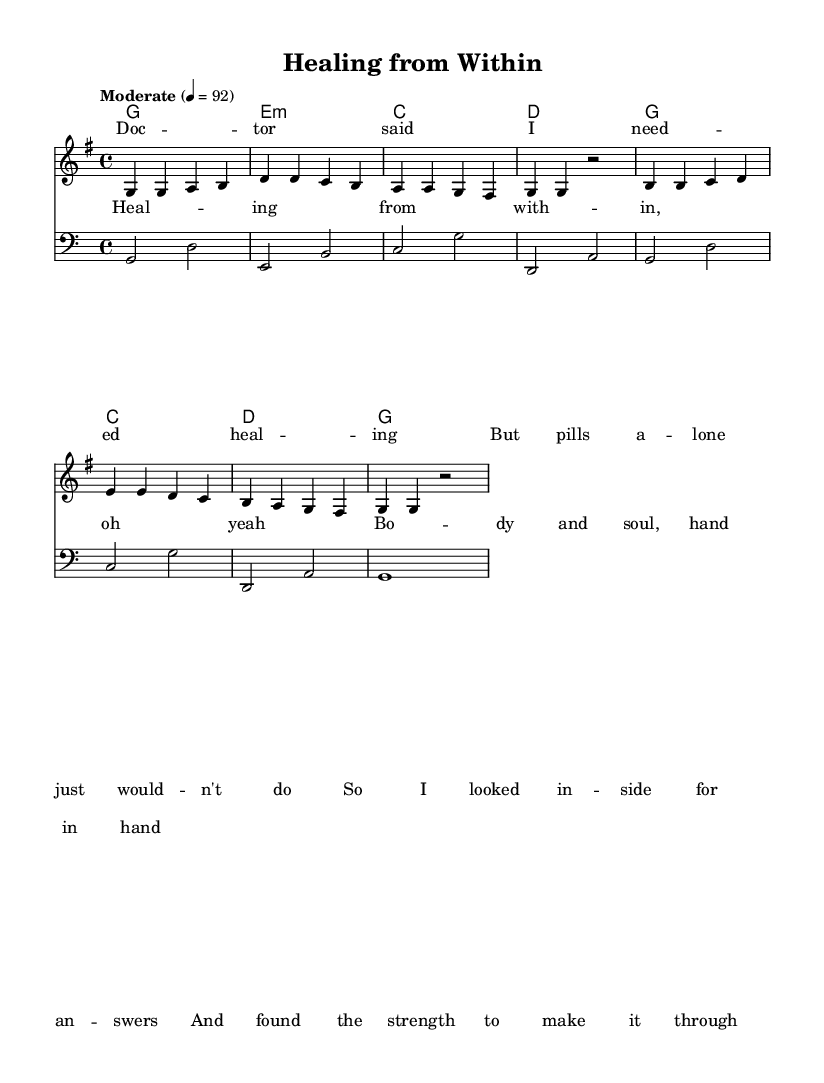What is the key signature of this music? The key signature is G major, which contains one sharp (F#). This can be identified at the beginning of the staff where the sharp symbol is placed.
Answer: G major What is the time signature of this music? The time signature displayed at the beginning is 4/4, indicating four beats per measure, with a quarter note receiving one beat. This is noted directly following the key signature.
Answer: 4/4 What is the tempo marking for this piece? The tempo marking is "Moderate," set at a quarter note = 92 beats per minute. This is commonly found near the title of the score, informing musicians about the expected speed of the piece.
Answer: Moderate, 92 How many measures are in the melody section provided? The melody section shows four measures in the first line and four in the second line, totaling eight measures. By counting the vertical lines separating each measure, we can determine the total.
Answer: 8 What is the main theme of the lyrics in this song? The lyrics focus on the theme of healing from within, as described in the verses and chorus. Interpreting the words from the lyric sections reveals an emphasis on self-discovery and resilience.
Answer: Healing from within Which instrument is represented in the bass staff? The bass staff is indicated with a clef that represents lower pitch notes, specifically designed for bass instruments, such as the bass guitar or double bass.
Answer: Bass How does the chorus relate to the verses in terms of message? The chorus reinforces the central message of seeking healing and emotional restoration, which resonates throughout the verses that discuss the journey towards personal health. The repeated phrases in lyrics suggest a strong connection to the ones in the verses.
Answer: Strength and connection 